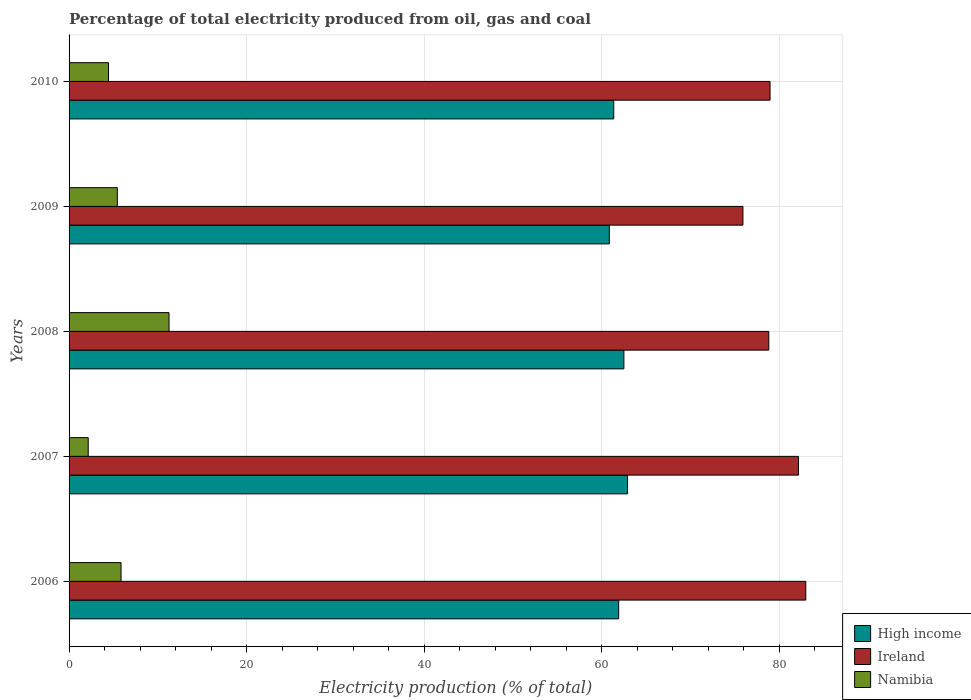Are the number of bars on each tick of the Y-axis equal?
Keep it short and to the point. Yes. In how many cases, is the number of bars for a given year not equal to the number of legend labels?
Your answer should be compact. 0. What is the electricity production in in Ireland in 2008?
Provide a succinct answer. 78.82. Across all years, what is the maximum electricity production in in Ireland?
Offer a terse response. 82.99. Across all years, what is the minimum electricity production in in Ireland?
Make the answer very short. 75.91. What is the total electricity production in in High income in the graph?
Your answer should be very brief. 309.53. What is the difference between the electricity production in in Namibia in 2006 and that in 2008?
Offer a terse response. -5.41. What is the difference between the electricity production in in High income in 2010 and the electricity production in in Namibia in 2007?
Ensure brevity in your answer.  59.2. What is the average electricity production in in High income per year?
Your response must be concise. 61.91. In the year 2009, what is the difference between the electricity production in in Ireland and electricity production in in Namibia?
Provide a short and direct response. 70.47. What is the ratio of the electricity production in in Namibia in 2006 to that in 2007?
Offer a terse response. 2.71. What is the difference between the highest and the second highest electricity production in in High income?
Offer a terse response. 0.41. What is the difference between the highest and the lowest electricity production in in Ireland?
Provide a short and direct response. 7.08. What does the 2nd bar from the top in 2009 represents?
Provide a short and direct response. Ireland. How many bars are there?
Give a very brief answer. 15. Are all the bars in the graph horizontal?
Provide a short and direct response. Yes. What is the title of the graph?
Offer a terse response. Percentage of total electricity produced from oil, gas and coal. Does "Cuba" appear as one of the legend labels in the graph?
Your answer should be compact. No. What is the label or title of the X-axis?
Offer a terse response. Electricity production (% of total). What is the label or title of the Y-axis?
Your answer should be compact. Years. What is the Electricity production (% of total) in High income in 2006?
Offer a terse response. 61.91. What is the Electricity production (% of total) of Ireland in 2006?
Ensure brevity in your answer.  82.99. What is the Electricity production (% of total) of Namibia in 2006?
Give a very brief answer. 5.85. What is the Electricity production (% of total) of High income in 2007?
Your answer should be very brief. 62.91. What is the Electricity production (% of total) of Ireland in 2007?
Provide a short and direct response. 82.17. What is the Electricity production (% of total) of Namibia in 2007?
Make the answer very short. 2.16. What is the Electricity production (% of total) of High income in 2008?
Your answer should be compact. 62.5. What is the Electricity production (% of total) in Ireland in 2008?
Offer a terse response. 78.82. What is the Electricity production (% of total) in Namibia in 2008?
Make the answer very short. 11.26. What is the Electricity production (% of total) of High income in 2009?
Give a very brief answer. 60.86. What is the Electricity production (% of total) of Ireland in 2009?
Your answer should be very brief. 75.91. What is the Electricity production (% of total) in Namibia in 2009?
Provide a short and direct response. 5.44. What is the Electricity production (% of total) in High income in 2010?
Offer a very short reply. 61.36. What is the Electricity production (% of total) of Ireland in 2010?
Offer a terse response. 78.96. What is the Electricity production (% of total) in Namibia in 2010?
Provide a succinct answer. 4.44. Across all years, what is the maximum Electricity production (% of total) of High income?
Offer a terse response. 62.91. Across all years, what is the maximum Electricity production (% of total) of Ireland?
Offer a very short reply. 82.99. Across all years, what is the maximum Electricity production (% of total) of Namibia?
Offer a very short reply. 11.26. Across all years, what is the minimum Electricity production (% of total) in High income?
Your response must be concise. 60.86. Across all years, what is the minimum Electricity production (% of total) of Ireland?
Make the answer very short. 75.91. Across all years, what is the minimum Electricity production (% of total) in Namibia?
Ensure brevity in your answer.  2.16. What is the total Electricity production (% of total) in High income in the graph?
Offer a very short reply. 309.53. What is the total Electricity production (% of total) in Ireland in the graph?
Give a very brief answer. 398.85. What is the total Electricity production (% of total) in Namibia in the graph?
Give a very brief answer. 29.15. What is the difference between the Electricity production (% of total) of High income in 2006 and that in 2007?
Provide a succinct answer. -1. What is the difference between the Electricity production (% of total) in Ireland in 2006 and that in 2007?
Your answer should be compact. 0.82. What is the difference between the Electricity production (% of total) of Namibia in 2006 and that in 2007?
Your response must be concise. 3.7. What is the difference between the Electricity production (% of total) of High income in 2006 and that in 2008?
Give a very brief answer. -0.59. What is the difference between the Electricity production (% of total) of Ireland in 2006 and that in 2008?
Your response must be concise. 4.17. What is the difference between the Electricity production (% of total) in Namibia in 2006 and that in 2008?
Give a very brief answer. -5.41. What is the difference between the Electricity production (% of total) of High income in 2006 and that in 2009?
Provide a short and direct response. 1.05. What is the difference between the Electricity production (% of total) of Ireland in 2006 and that in 2009?
Ensure brevity in your answer.  7.08. What is the difference between the Electricity production (% of total) of Namibia in 2006 and that in 2009?
Provide a succinct answer. 0.42. What is the difference between the Electricity production (% of total) in High income in 2006 and that in 2010?
Provide a short and direct response. 0.56. What is the difference between the Electricity production (% of total) of Ireland in 2006 and that in 2010?
Make the answer very short. 4.03. What is the difference between the Electricity production (% of total) in Namibia in 2006 and that in 2010?
Provide a succinct answer. 1.41. What is the difference between the Electricity production (% of total) of High income in 2007 and that in 2008?
Your answer should be very brief. 0.41. What is the difference between the Electricity production (% of total) of Ireland in 2007 and that in 2008?
Keep it short and to the point. 3.35. What is the difference between the Electricity production (% of total) in Namibia in 2007 and that in 2008?
Your answer should be compact. -9.1. What is the difference between the Electricity production (% of total) in High income in 2007 and that in 2009?
Make the answer very short. 2.06. What is the difference between the Electricity production (% of total) of Ireland in 2007 and that in 2009?
Offer a very short reply. 6.26. What is the difference between the Electricity production (% of total) of Namibia in 2007 and that in 2009?
Offer a terse response. -3.28. What is the difference between the Electricity production (% of total) of High income in 2007 and that in 2010?
Your response must be concise. 1.56. What is the difference between the Electricity production (% of total) of Ireland in 2007 and that in 2010?
Ensure brevity in your answer.  3.21. What is the difference between the Electricity production (% of total) in Namibia in 2007 and that in 2010?
Provide a succinct answer. -2.29. What is the difference between the Electricity production (% of total) of High income in 2008 and that in 2009?
Offer a terse response. 1.64. What is the difference between the Electricity production (% of total) in Ireland in 2008 and that in 2009?
Offer a terse response. 2.92. What is the difference between the Electricity production (% of total) in Namibia in 2008 and that in 2009?
Your response must be concise. 5.82. What is the difference between the Electricity production (% of total) of High income in 2008 and that in 2010?
Give a very brief answer. 1.14. What is the difference between the Electricity production (% of total) in Ireland in 2008 and that in 2010?
Offer a terse response. -0.14. What is the difference between the Electricity production (% of total) of Namibia in 2008 and that in 2010?
Keep it short and to the point. 6.82. What is the difference between the Electricity production (% of total) of High income in 2009 and that in 2010?
Make the answer very short. -0.5. What is the difference between the Electricity production (% of total) of Ireland in 2009 and that in 2010?
Your answer should be very brief. -3.06. What is the difference between the Electricity production (% of total) of High income in 2006 and the Electricity production (% of total) of Ireland in 2007?
Keep it short and to the point. -20.26. What is the difference between the Electricity production (% of total) of High income in 2006 and the Electricity production (% of total) of Namibia in 2007?
Your answer should be very brief. 59.75. What is the difference between the Electricity production (% of total) in Ireland in 2006 and the Electricity production (% of total) in Namibia in 2007?
Offer a very short reply. 80.83. What is the difference between the Electricity production (% of total) of High income in 2006 and the Electricity production (% of total) of Ireland in 2008?
Keep it short and to the point. -16.91. What is the difference between the Electricity production (% of total) of High income in 2006 and the Electricity production (% of total) of Namibia in 2008?
Your answer should be compact. 50.65. What is the difference between the Electricity production (% of total) of Ireland in 2006 and the Electricity production (% of total) of Namibia in 2008?
Your response must be concise. 71.73. What is the difference between the Electricity production (% of total) in High income in 2006 and the Electricity production (% of total) in Ireland in 2009?
Provide a succinct answer. -14. What is the difference between the Electricity production (% of total) of High income in 2006 and the Electricity production (% of total) of Namibia in 2009?
Your answer should be very brief. 56.47. What is the difference between the Electricity production (% of total) of Ireland in 2006 and the Electricity production (% of total) of Namibia in 2009?
Offer a very short reply. 77.55. What is the difference between the Electricity production (% of total) of High income in 2006 and the Electricity production (% of total) of Ireland in 2010?
Keep it short and to the point. -17.05. What is the difference between the Electricity production (% of total) in High income in 2006 and the Electricity production (% of total) in Namibia in 2010?
Provide a short and direct response. 57.47. What is the difference between the Electricity production (% of total) in Ireland in 2006 and the Electricity production (% of total) in Namibia in 2010?
Ensure brevity in your answer.  78.54. What is the difference between the Electricity production (% of total) in High income in 2007 and the Electricity production (% of total) in Ireland in 2008?
Your answer should be very brief. -15.91. What is the difference between the Electricity production (% of total) in High income in 2007 and the Electricity production (% of total) in Namibia in 2008?
Your answer should be very brief. 51.65. What is the difference between the Electricity production (% of total) in Ireland in 2007 and the Electricity production (% of total) in Namibia in 2008?
Provide a succinct answer. 70.91. What is the difference between the Electricity production (% of total) of High income in 2007 and the Electricity production (% of total) of Ireland in 2009?
Offer a very short reply. -12.99. What is the difference between the Electricity production (% of total) in High income in 2007 and the Electricity production (% of total) in Namibia in 2009?
Provide a short and direct response. 57.48. What is the difference between the Electricity production (% of total) in Ireland in 2007 and the Electricity production (% of total) in Namibia in 2009?
Your answer should be compact. 76.73. What is the difference between the Electricity production (% of total) in High income in 2007 and the Electricity production (% of total) in Ireland in 2010?
Keep it short and to the point. -16.05. What is the difference between the Electricity production (% of total) in High income in 2007 and the Electricity production (% of total) in Namibia in 2010?
Give a very brief answer. 58.47. What is the difference between the Electricity production (% of total) of Ireland in 2007 and the Electricity production (% of total) of Namibia in 2010?
Offer a terse response. 77.72. What is the difference between the Electricity production (% of total) in High income in 2008 and the Electricity production (% of total) in Ireland in 2009?
Keep it short and to the point. -13.41. What is the difference between the Electricity production (% of total) of High income in 2008 and the Electricity production (% of total) of Namibia in 2009?
Make the answer very short. 57.06. What is the difference between the Electricity production (% of total) in Ireland in 2008 and the Electricity production (% of total) in Namibia in 2009?
Ensure brevity in your answer.  73.39. What is the difference between the Electricity production (% of total) of High income in 2008 and the Electricity production (% of total) of Ireland in 2010?
Offer a terse response. -16.46. What is the difference between the Electricity production (% of total) in High income in 2008 and the Electricity production (% of total) in Namibia in 2010?
Provide a succinct answer. 58.05. What is the difference between the Electricity production (% of total) in Ireland in 2008 and the Electricity production (% of total) in Namibia in 2010?
Make the answer very short. 74.38. What is the difference between the Electricity production (% of total) of High income in 2009 and the Electricity production (% of total) of Ireland in 2010?
Provide a short and direct response. -18.11. What is the difference between the Electricity production (% of total) in High income in 2009 and the Electricity production (% of total) in Namibia in 2010?
Provide a short and direct response. 56.41. What is the difference between the Electricity production (% of total) of Ireland in 2009 and the Electricity production (% of total) of Namibia in 2010?
Your answer should be compact. 71.46. What is the average Electricity production (% of total) of High income per year?
Keep it short and to the point. 61.91. What is the average Electricity production (% of total) of Ireland per year?
Provide a succinct answer. 79.77. What is the average Electricity production (% of total) in Namibia per year?
Offer a terse response. 5.83. In the year 2006, what is the difference between the Electricity production (% of total) in High income and Electricity production (% of total) in Ireland?
Provide a short and direct response. -21.08. In the year 2006, what is the difference between the Electricity production (% of total) in High income and Electricity production (% of total) in Namibia?
Make the answer very short. 56.06. In the year 2006, what is the difference between the Electricity production (% of total) in Ireland and Electricity production (% of total) in Namibia?
Ensure brevity in your answer.  77.13. In the year 2007, what is the difference between the Electricity production (% of total) in High income and Electricity production (% of total) in Ireland?
Your answer should be compact. -19.26. In the year 2007, what is the difference between the Electricity production (% of total) of High income and Electricity production (% of total) of Namibia?
Your answer should be compact. 60.76. In the year 2007, what is the difference between the Electricity production (% of total) in Ireland and Electricity production (% of total) in Namibia?
Your answer should be compact. 80.01. In the year 2008, what is the difference between the Electricity production (% of total) in High income and Electricity production (% of total) in Ireland?
Offer a terse response. -16.32. In the year 2008, what is the difference between the Electricity production (% of total) in High income and Electricity production (% of total) in Namibia?
Offer a terse response. 51.24. In the year 2008, what is the difference between the Electricity production (% of total) in Ireland and Electricity production (% of total) in Namibia?
Your answer should be compact. 67.56. In the year 2009, what is the difference between the Electricity production (% of total) of High income and Electricity production (% of total) of Ireland?
Your answer should be compact. -15.05. In the year 2009, what is the difference between the Electricity production (% of total) in High income and Electricity production (% of total) in Namibia?
Your answer should be very brief. 55.42. In the year 2009, what is the difference between the Electricity production (% of total) of Ireland and Electricity production (% of total) of Namibia?
Give a very brief answer. 70.47. In the year 2010, what is the difference between the Electricity production (% of total) in High income and Electricity production (% of total) in Ireland?
Offer a terse response. -17.61. In the year 2010, what is the difference between the Electricity production (% of total) of High income and Electricity production (% of total) of Namibia?
Your answer should be very brief. 56.91. In the year 2010, what is the difference between the Electricity production (% of total) of Ireland and Electricity production (% of total) of Namibia?
Ensure brevity in your answer.  74.52. What is the ratio of the Electricity production (% of total) in High income in 2006 to that in 2007?
Your answer should be compact. 0.98. What is the ratio of the Electricity production (% of total) of Ireland in 2006 to that in 2007?
Make the answer very short. 1.01. What is the ratio of the Electricity production (% of total) in Namibia in 2006 to that in 2007?
Your answer should be very brief. 2.71. What is the ratio of the Electricity production (% of total) in High income in 2006 to that in 2008?
Provide a short and direct response. 0.99. What is the ratio of the Electricity production (% of total) in Ireland in 2006 to that in 2008?
Keep it short and to the point. 1.05. What is the ratio of the Electricity production (% of total) in Namibia in 2006 to that in 2008?
Give a very brief answer. 0.52. What is the ratio of the Electricity production (% of total) of High income in 2006 to that in 2009?
Provide a short and direct response. 1.02. What is the ratio of the Electricity production (% of total) in Ireland in 2006 to that in 2009?
Offer a terse response. 1.09. What is the ratio of the Electricity production (% of total) in Namibia in 2006 to that in 2009?
Provide a short and direct response. 1.08. What is the ratio of the Electricity production (% of total) of High income in 2006 to that in 2010?
Provide a succinct answer. 1.01. What is the ratio of the Electricity production (% of total) of Ireland in 2006 to that in 2010?
Keep it short and to the point. 1.05. What is the ratio of the Electricity production (% of total) in Namibia in 2006 to that in 2010?
Make the answer very short. 1.32. What is the ratio of the Electricity production (% of total) in High income in 2007 to that in 2008?
Offer a terse response. 1.01. What is the ratio of the Electricity production (% of total) in Ireland in 2007 to that in 2008?
Ensure brevity in your answer.  1.04. What is the ratio of the Electricity production (% of total) of Namibia in 2007 to that in 2008?
Give a very brief answer. 0.19. What is the ratio of the Electricity production (% of total) of High income in 2007 to that in 2009?
Your response must be concise. 1.03. What is the ratio of the Electricity production (% of total) of Ireland in 2007 to that in 2009?
Provide a short and direct response. 1.08. What is the ratio of the Electricity production (% of total) in Namibia in 2007 to that in 2009?
Keep it short and to the point. 0.4. What is the ratio of the Electricity production (% of total) of High income in 2007 to that in 2010?
Provide a short and direct response. 1.03. What is the ratio of the Electricity production (% of total) of Ireland in 2007 to that in 2010?
Make the answer very short. 1.04. What is the ratio of the Electricity production (% of total) of Namibia in 2007 to that in 2010?
Ensure brevity in your answer.  0.49. What is the ratio of the Electricity production (% of total) in High income in 2008 to that in 2009?
Give a very brief answer. 1.03. What is the ratio of the Electricity production (% of total) of Ireland in 2008 to that in 2009?
Offer a terse response. 1.04. What is the ratio of the Electricity production (% of total) of Namibia in 2008 to that in 2009?
Provide a short and direct response. 2.07. What is the ratio of the Electricity production (% of total) of High income in 2008 to that in 2010?
Provide a short and direct response. 1.02. What is the ratio of the Electricity production (% of total) of Ireland in 2008 to that in 2010?
Provide a short and direct response. 1. What is the ratio of the Electricity production (% of total) in Namibia in 2008 to that in 2010?
Your answer should be very brief. 2.53. What is the ratio of the Electricity production (% of total) in High income in 2009 to that in 2010?
Offer a terse response. 0.99. What is the ratio of the Electricity production (% of total) of Ireland in 2009 to that in 2010?
Your answer should be compact. 0.96. What is the ratio of the Electricity production (% of total) of Namibia in 2009 to that in 2010?
Your response must be concise. 1.22. What is the difference between the highest and the second highest Electricity production (% of total) in High income?
Ensure brevity in your answer.  0.41. What is the difference between the highest and the second highest Electricity production (% of total) of Ireland?
Give a very brief answer. 0.82. What is the difference between the highest and the second highest Electricity production (% of total) in Namibia?
Provide a short and direct response. 5.41. What is the difference between the highest and the lowest Electricity production (% of total) in High income?
Provide a short and direct response. 2.06. What is the difference between the highest and the lowest Electricity production (% of total) of Ireland?
Provide a succinct answer. 7.08. What is the difference between the highest and the lowest Electricity production (% of total) in Namibia?
Your response must be concise. 9.1. 